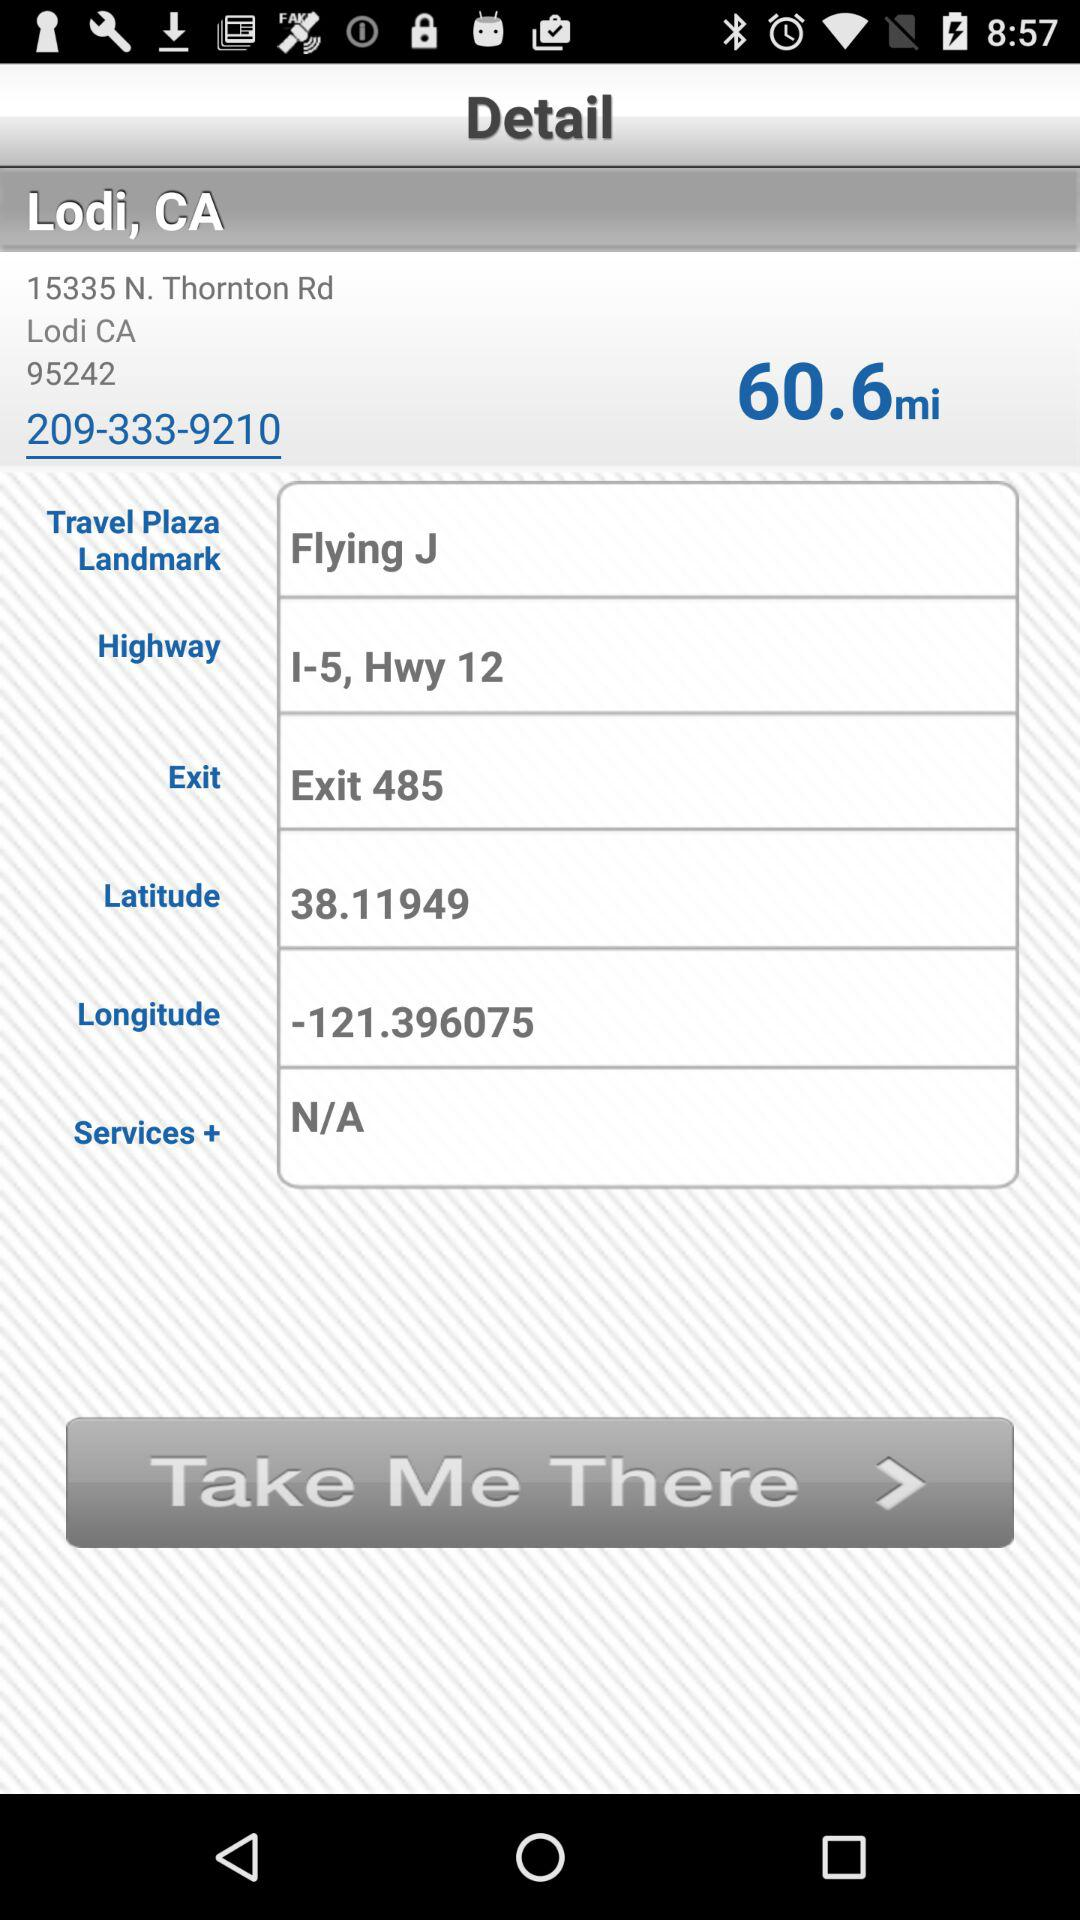What is the name of the user?
When the provided information is insufficient, respond with <no answer>. <no answer> 